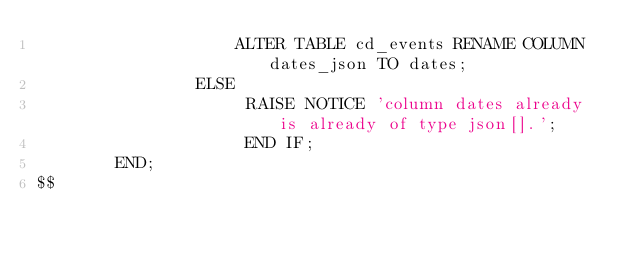<code> <loc_0><loc_0><loc_500><loc_500><_SQL_>					ALTER TABLE cd_events RENAME COLUMN dates_json TO dates;
				ELSE
					 RAISE NOTICE 'column dates already is already of type json[].';
					 END IF;
		END;
$$</code> 